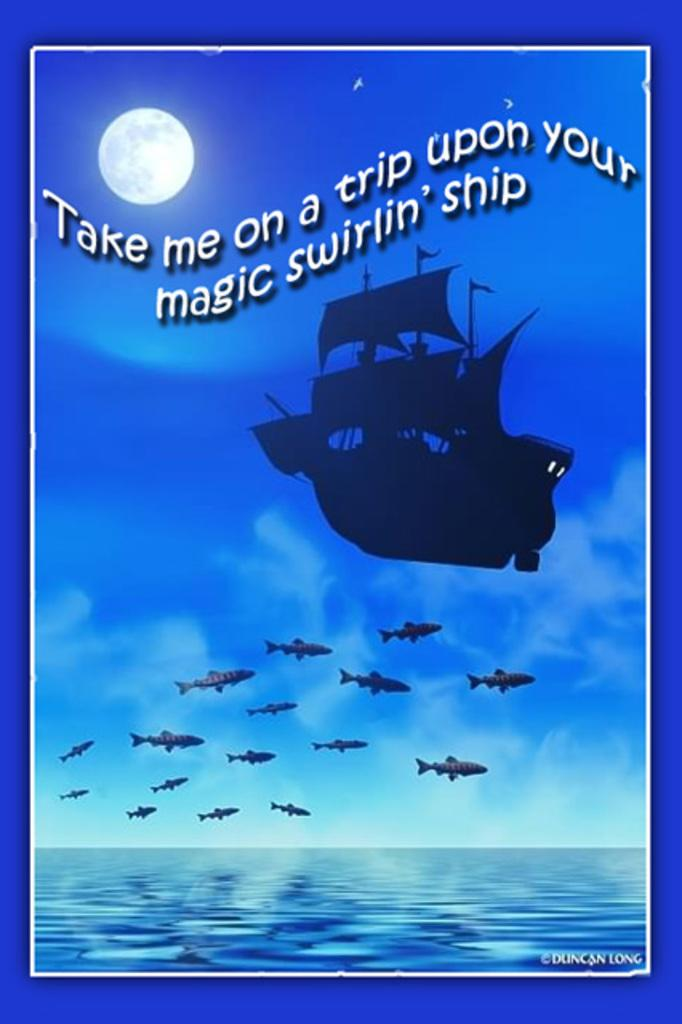What is the main subject of the image? There is a ship in the image. What else can be seen in the image besides the ship? There are fishes and a sea at the bottom of the image. What is visible in the sky in the image? There is a moon in the sky. What is written or depicted at the top of the image? There is a text at the top of the image. What type of ornament is hanging from the ship's mast in the image? There is no ornament hanging from the ship's mast in the image. Can you see any yaks in the image? There are no yaks present in the image. 